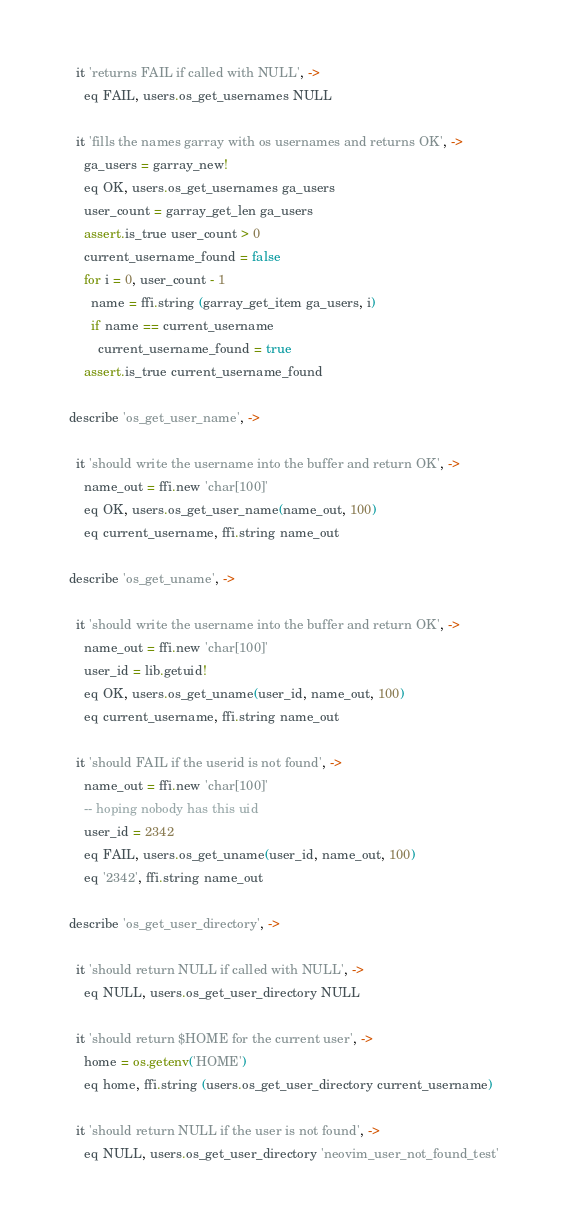Convert code to text. <code><loc_0><loc_0><loc_500><loc_500><_MoonScript_>
    it 'returns FAIL if called with NULL', ->
      eq FAIL, users.os_get_usernames NULL

    it 'fills the names garray with os usernames and returns OK', ->
      ga_users = garray_new!
      eq OK, users.os_get_usernames ga_users
      user_count = garray_get_len ga_users
      assert.is_true user_count > 0
      current_username_found = false
      for i = 0, user_count - 1
        name = ffi.string (garray_get_item ga_users, i)
        if name == current_username
          current_username_found = true
      assert.is_true current_username_found

  describe 'os_get_user_name', ->

    it 'should write the username into the buffer and return OK', ->
      name_out = ffi.new 'char[100]'
      eq OK, users.os_get_user_name(name_out, 100)
      eq current_username, ffi.string name_out

  describe 'os_get_uname', ->

    it 'should write the username into the buffer and return OK', ->
      name_out = ffi.new 'char[100]'
      user_id = lib.getuid!
      eq OK, users.os_get_uname(user_id, name_out, 100)
      eq current_username, ffi.string name_out

    it 'should FAIL if the userid is not found', ->
      name_out = ffi.new 'char[100]'
      -- hoping nobody has this uid
      user_id = 2342
      eq FAIL, users.os_get_uname(user_id, name_out, 100)
      eq '2342', ffi.string name_out

  describe 'os_get_user_directory', ->

    it 'should return NULL if called with NULL', ->
      eq NULL, users.os_get_user_directory NULL

    it 'should return $HOME for the current user', ->
      home = os.getenv('HOME')
      eq home, ffi.string (users.os_get_user_directory current_username)

    it 'should return NULL if the user is not found', ->
      eq NULL, users.os_get_user_directory 'neovim_user_not_found_test'

</code> 